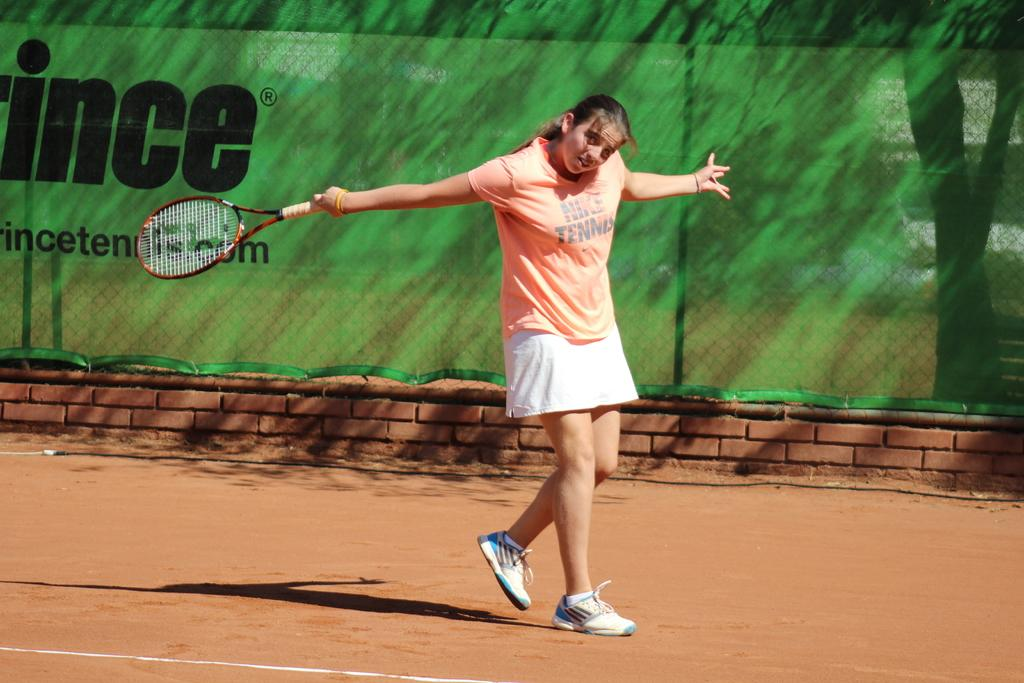What is present in the image? There is a woman in the image. What is the woman doing in the image? The woman is walking in the image. What is the woman doing with her hands in the image? The woman is catching a bat with her hands in the image. What type of stem can be seen growing from the woman's head in the image? There is no stem growing from the woman's head in the image. How many bears are visible in the image? There are no bears present in the image. 